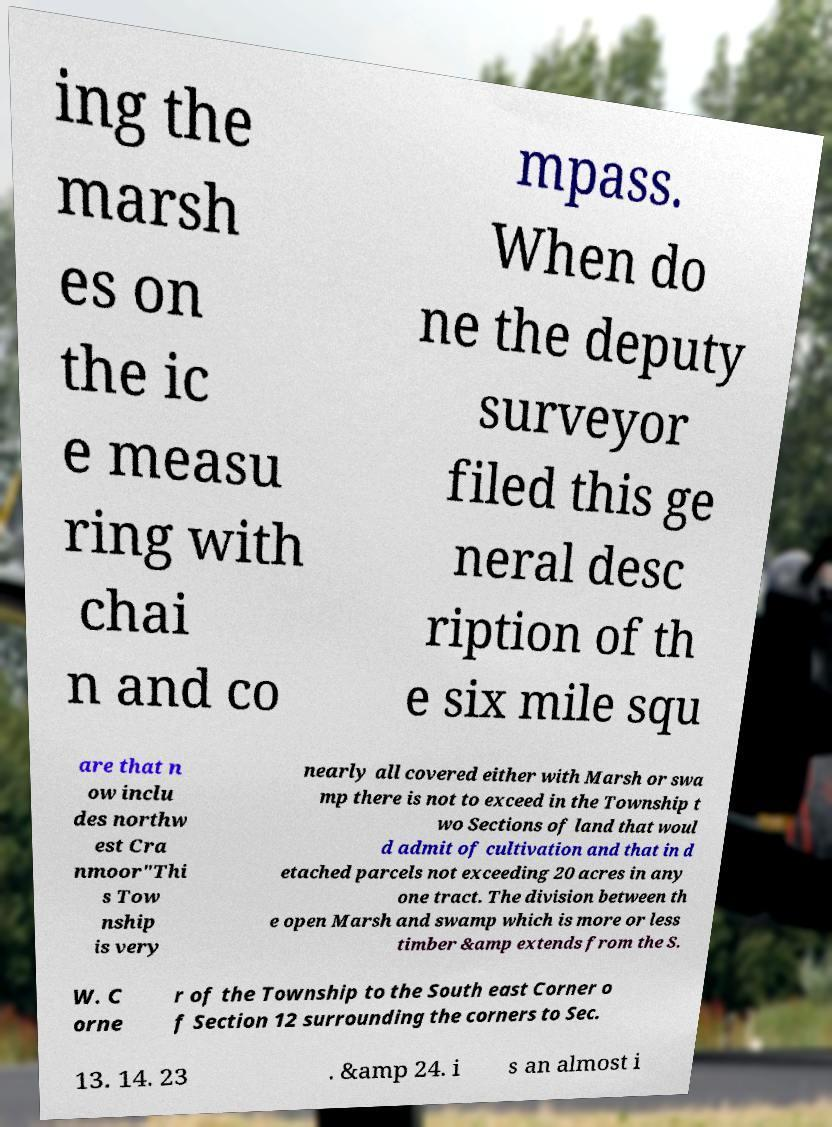Please identify and transcribe the text found in this image. ing the marsh es on the ic e measu ring with chai n and co mpass. When do ne the deputy surveyor filed this ge neral desc ription of th e six mile squ are that n ow inclu des northw est Cra nmoor"Thi s Tow nship is very nearly all covered either with Marsh or swa mp there is not to exceed in the Township t wo Sections of land that woul d admit of cultivation and that in d etached parcels not exceeding 20 acres in any one tract. The division between th e open Marsh and swamp which is more or less timber &amp extends from the S. W. C orne r of the Township to the South east Corner o f Section 12 surrounding the corners to Sec. 13. 14. 23 . &amp 24. i s an almost i 